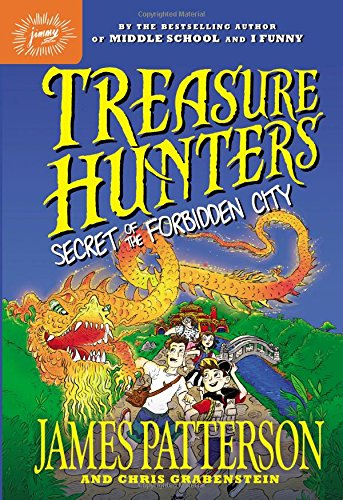Is this book related to Mystery, Thriller & Suspense? Yes, the book is indeed a part of the Mystery, Thriller & Suspense genre, perfect for those who enjoy a good puzzle and action-packed storylines. 